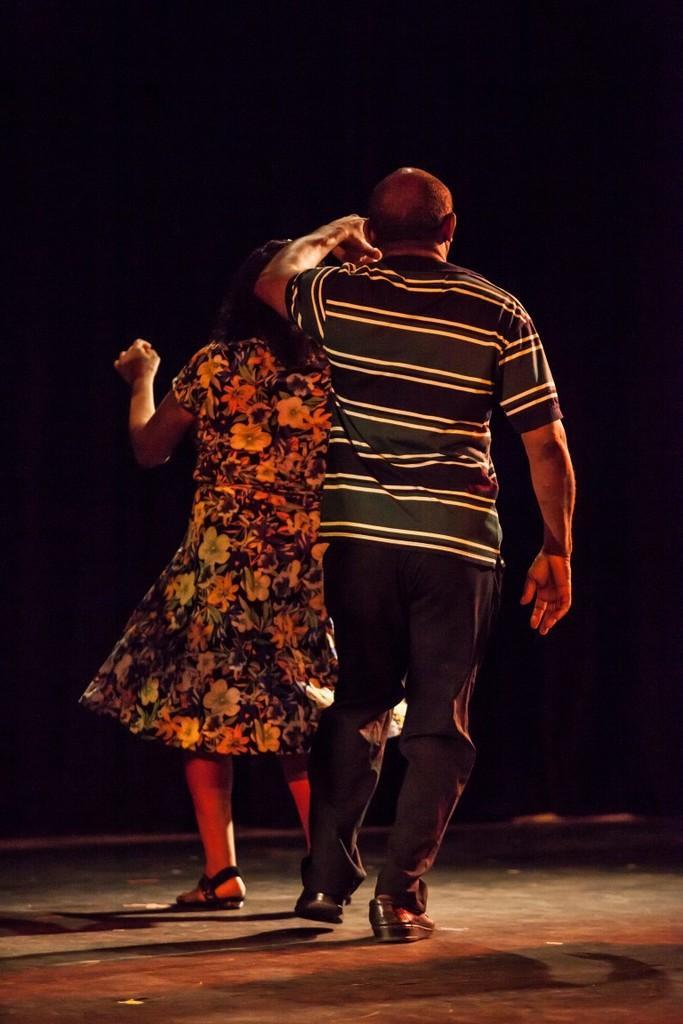In one or two sentences, can you explain what this image depicts? Background portion of the picture is completely dark. In this picture we can see a woman wearing a floral dress and we can see a man wearing a t-shirt. It seems like they are dancing. 